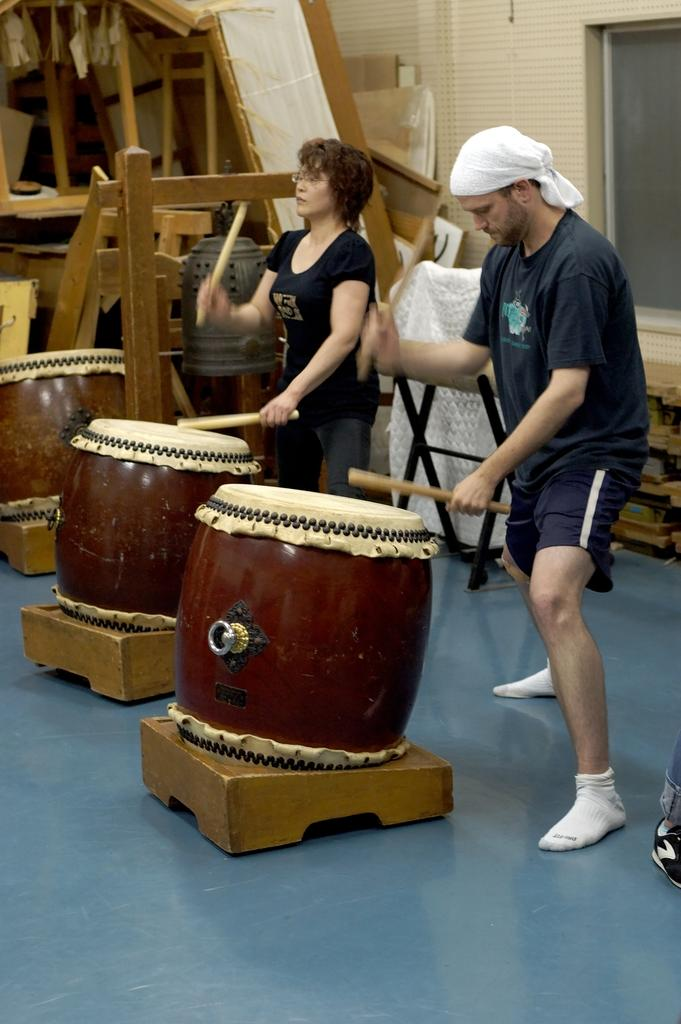How many people are in the image? There are two persons in the image. What are the two persons doing in the image? The two persons are beating drums. What can be seen in the background of the image? There are wooden objects in the background of the image. What type of root can be seen growing near the drummers in the image? There is no root visible in the image; it only features two persons beating drums and wooden objects in the background. 